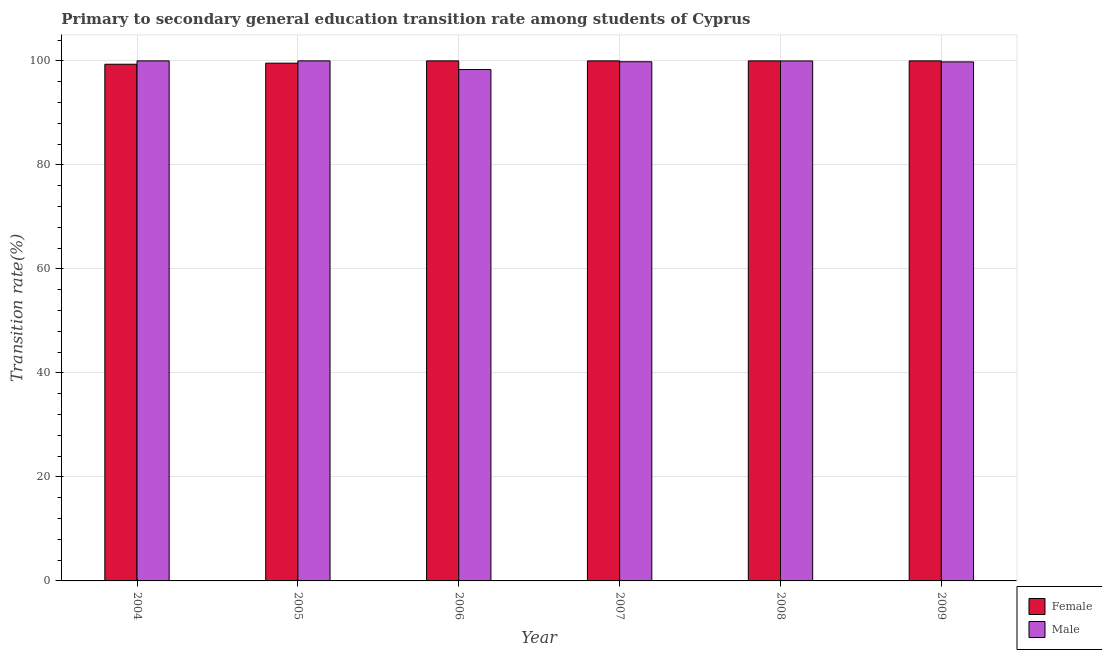How many bars are there on the 5th tick from the left?
Give a very brief answer. 2. What is the transition rate among male students in 2007?
Your answer should be very brief. 99.83. Across all years, what is the maximum transition rate among male students?
Your answer should be very brief. 100. Across all years, what is the minimum transition rate among male students?
Provide a succinct answer. 98.33. What is the total transition rate among female students in the graph?
Your answer should be compact. 598.91. What is the difference between the transition rate among male students in 2004 and that in 2006?
Keep it short and to the point. 1.67. What is the difference between the transition rate among female students in 2004 and the transition rate among male students in 2007?
Keep it short and to the point. -0.65. What is the average transition rate among female students per year?
Offer a very short reply. 99.82. In the year 2005, what is the difference between the transition rate among male students and transition rate among female students?
Provide a succinct answer. 0. What is the ratio of the transition rate among male students in 2006 to that in 2008?
Give a very brief answer. 0.98. Is the transition rate among female students in 2005 less than that in 2006?
Provide a short and direct response. Yes. What is the difference between the highest and the second highest transition rate among male students?
Give a very brief answer. 0. What is the difference between the highest and the lowest transition rate among female students?
Provide a short and direct response. 0.65. In how many years, is the transition rate among female students greater than the average transition rate among female students taken over all years?
Your answer should be very brief. 4. What does the 1st bar from the right in 2005 represents?
Make the answer very short. Male. Are the values on the major ticks of Y-axis written in scientific E-notation?
Your answer should be compact. No. Does the graph contain any zero values?
Your response must be concise. No. Does the graph contain grids?
Keep it short and to the point. Yes. Where does the legend appear in the graph?
Provide a short and direct response. Bottom right. How are the legend labels stacked?
Provide a succinct answer. Vertical. What is the title of the graph?
Make the answer very short. Primary to secondary general education transition rate among students of Cyprus. Does "Sanitation services" appear as one of the legend labels in the graph?
Provide a short and direct response. No. What is the label or title of the Y-axis?
Offer a very short reply. Transition rate(%). What is the Transition rate(%) of Female in 2004?
Provide a short and direct response. 99.35. What is the Transition rate(%) in Female in 2005?
Keep it short and to the point. 99.56. What is the Transition rate(%) of Female in 2006?
Give a very brief answer. 100. What is the Transition rate(%) in Male in 2006?
Your answer should be very brief. 98.33. What is the Transition rate(%) of Female in 2007?
Make the answer very short. 100. What is the Transition rate(%) in Male in 2007?
Keep it short and to the point. 99.83. What is the Transition rate(%) of Female in 2008?
Your answer should be compact. 100. What is the Transition rate(%) of Male in 2008?
Keep it short and to the point. 99.99. What is the Transition rate(%) of Female in 2009?
Ensure brevity in your answer.  100. What is the Transition rate(%) in Male in 2009?
Keep it short and to the point. 99.81. Across all years, what is the maximum Transition rate(%) of Female?
Make the answer very short. 100. Across all years, what is the minimum Transition rate(%) in Female?
Provide a short and direct response. 99.35. Across all years, what is the minimum Transition rate(%) in Male?
Keep it short and to the point. 98.33. What is the total Transition rate(%) in Female in the graph?
Make the answer very short. 598.91. What is the total Transition rate(%) in Male in the graph?
Your answer should be compact. 597.96. What is the difference between the Transition rate(%) in Female in 2004 and that in 2005?
Give a very brief answer. -0.21. What is the difference between the Transition rate(%) of Male in 2004 and that in 2005?
Ensure brevity in your answer.  0. What is the difference between the Transition rate(%) of Female in 2004 and that in 2006?
Provide a succinct answer. -0.65. What is the difference between the Transition rate(%) in Male in 2004 and that in 2006?
Ensure brevity in your answer.  1.67. What is the difference between the Transition rate(%) in Female in 2004 and that in 2007?
Your answer should be very brief. -0.65. What is the difference between the Transition rate(%) in Male in 2004 and that in 2007?
Make the answer very short. 0.17. What is the difference between the Transition rate(%) of Female in 2004 and that in 2008?
Make the answer very short. -0.65. What is the difference between the Transition rate(%) of Male in 2004 and that in 2008?
Your answer should be very brief. 0.01. What is the difference between the Transition rate(%) of Female in 2004 and that in 2009?
Offer a terse response. -0.65. What is the difference between the Transition rate(%) of Male in 2004 and that in 2009?
Offer a very short reply. 0.19. What is the difference between the Transition rate(%) in Female in 2005 and that in 2006?
Provide a succinct answer. -0.44. What is the difference between the Transition rate(%) in Male in 2005 and that in 2006?
Offer a terse response. 1.67. What is the difference between the Transition rate(%) of Female in 2005 and that in 2007?
Your answer should be very brief. -0.44. What is the difference between the Transition rate(%) in Male in 2005 and that in 2007?
Provide a short and direct response. 0.17. What is the difference between the Transition rate(%) in Female in 2005 and that in 2008?
Ensure brevity in your answer.  -0.44. What is the difference between the Transition rate(%) of Male in 2005 and that in 2008?
Give a very brief answer. 0.01. What is the difference between the Transition rate(%) in Female in 2005 and that in 2009?
Your answer should be very brief. -0.44. What is the difference between the Transition rate(%) of Male in 2005 and that in 2009?
Your answer should be very brief. 0.19. What is the difference between the Transition rate(%) in Female in 2006 and that in 2007?
Provide a succinct answer. 0. What is the difference between the Transition rate(%) in Male in 2006 and that in 2007?
Your answer should be compact. -1.5. What is the difference between the Transition rate(%) of Male in 2006 and that in 2008?
Offer a terse response. -1.66. What is the difference between the Transition rate(%) of Male in 2006 and that in 2009?
Your answer should be very brief. -1.48. What is the difference between the Transition rate(%) in Female in 2007 and that in 2008?
Offer a terse response. 0. What is the difference between the Transition rate(%) of Male in 2007 and that in 2008?
Give a very brief answer. -0.15. What is the difference between the Transition rate(%) of Male in 2007 and that in 2009?
Provide a short and direct response. 0.02. What is the difference between the Transition rate(%) in Female in 2008 and that in 2009?
Make the answer very short. 0. What is the difference between the Transition rate(%) of Male in 2008 and that in 2009?
Your answer should be compact. 0.18. What is the difference between the Transition rate(%) of Female in 2004 and the Transition rate(%) of Male in 2005?
Give a very brief answer. -0.65. What is the difference between the Transition rate(%) in Female in 2004 and the Transition rate(%) in Male in 2006?
Offer a terse response. 1.02. What is the difference between the Transition rate(%) of Female in 2004 and the Transition rate(%) of Male in 2007?
Your answer should be compact. -0.48. What is the difference between the Transition rate(%) in Female in 2004 and the Transition rate(%) in Male in 2008?
Give a very brief answer. -0.64. What is the difference between the Transition rate(%) in Female in 2004 and the Transition rate(%) in Male in 2009?
Offer a terse response. -0.46. What is the difference between the Transition rate(%) of Female in 2005 and the Transition rate(%) of Male in 2006?
Your answer should be compact. 1.23. What is the difference between the Transition rate(%) in Female in 2005 and the Transition rate(%) in Male in 2007?
Keep it short and to the point. -0.27. What is the difference between the Transition rate(%) of Female in 2005 and the Transition rate(%) of Male in 2008?
Make the answer very short. -0.43. What is the difference between the Transition rate(%) in Female in 2005 and the Transition rate(%) in Male in 2009?
Ensure brevity in your answer.  -0.25. What is the difference between the Transition rate(%) in Female in 2006 and the Transition rate(%) in Male in 2007?
Ensure brevity in your answer.  0.17. What is the difference between the Transition rate(%) of Female in 2006 and the Transition rate(%) of Male in 2008?
Make the answer very short. 0.01. What is the difference between the Transition rate(%) in Female in 2006 and the Transition rate(%) in Male in 2009?
Your response must be concise. 0.19. What is the difference between the Transition rate(%) of Female in 2007 and the Transition rate(%) of Male in 2008?
Your response must be concise. 0.01. What is the difference between the Transition rate(%) in Female in 2007 and the Transition rate(%) in Male in 2009?
Your response must be concise. 0.19. What is the difference between the Transition rate(%) in Female in 2008 and the Transition rate(%) in Male in 2009?
Ensure brevity in your answer.  0.19. What is the average Transition rate(%) in Female per year?
Provide a short and direct response. 99.82. What is the average Transition rate(%) of Male per year?
Offer a very short reply. 99.66. In the year 2004, what is the difference between the Transition rate(%) in Female and Transition rate(%) in Male?
Keep it short and to the point. -0.65. In the year 2005, what is the difference between the Transition rate(%) of Female and Transition rate(%) of Male?
Make the answer very short. -0.44. In the year 2006, what is the difference between the Transition rate(%) of Female and Transition rate(%) of Male?
Provide a succinct answer. 1.67. In the year 2007, what is the difference between the Transition rate(%) in Female and Transition rate(%) in Male?
Offer a very short reply. 0.17. In the year 2008, what is the difference between the Transition rate(%) of Female and Transition rate(%) of Male?
Your answer should be very brief. 0.01. In the year 2009, what is the difference between the Transition rate(%) of Female and Transition rate(%) of Male?
Provide a short and direct response. 0.19. What is the ratio of the Transition rate(%) of Female in 2004 to that in 2005?
Your response must be concise. 1. What is the ratio of the Transition rate(%) of Male in 2004 to that in 2006?
Offer a very short reply. 1.02. What is the ratio of the Transition rate(%) in Female in 2004 to that in 2007?
Ensure brevity in your answer.  0.99. What is the ratio of the Transition rate(%) of Male in 2004 to that in 2008?
Provide a short and direct response. 1. What is the ratio of the Transition rate(%) in Female in 2004 to that in 2009?
Provide a short and direct response. 0.99. What is the ratio of the Transition rate(%) in Male in 2004 to that in 2009?
Offer a very short reply. 1. What is the ratio of the Transition rate(%) in Female in 2005 to that in 2006?
Your answer should be compact. 1. What is the ratio of the Transition rate(%) in Male in 2005 to that in 2006?
Provide a succinct answer. 1.02. What is the ratio of the Transition rate(%) of Male in 2005 to that in 2007?
Make the answer very short. 1. What is the ratio of the Transition rate(%) of Male in 2005 to that in 2009?
Provide a short and direct response. 1. What is the ratio of the Transition rate(%) in Male in 2006 to that in 2008?
Give a very brief answer. 0.98. What is the ratio of the Transition rate(%) of Male in 2006 to that in 2009?
Make the answer very short. 0.99. What is the ratio of the Transition rate(%) in Female in 2008 to that in 2009?
Provide a short and direct response. 1. What is the ratio of the Transition rate(%) of Male in 2008 to that in 2009?
Provide a short and direct response. 1. What is the difference between the highest and the second highest Transition rate(%) in Female?
Your response must be concise. 0. What is the difference between the highest and the lowest Transition rate(%) of Female?
Keep it short and to the point. 0.65. What is the difference between the highest and the lowest Transition rate(%) of Male?
Offer a terse response. 1.67. 